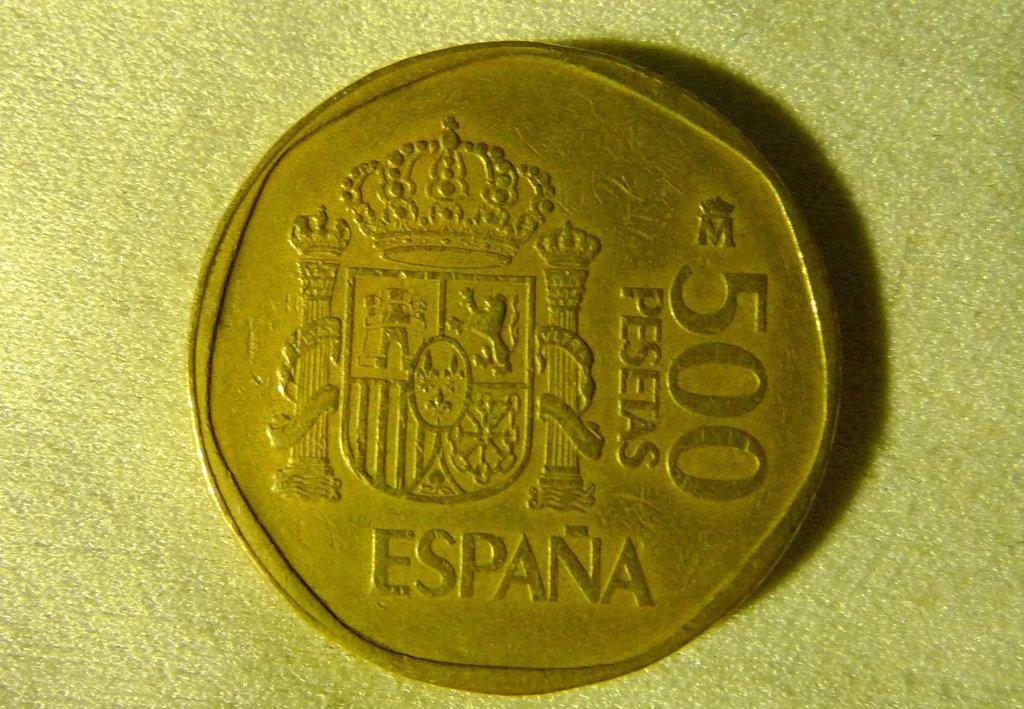Could you give a brief overview of what you see in this image? In the image we can see a coin on the table. 